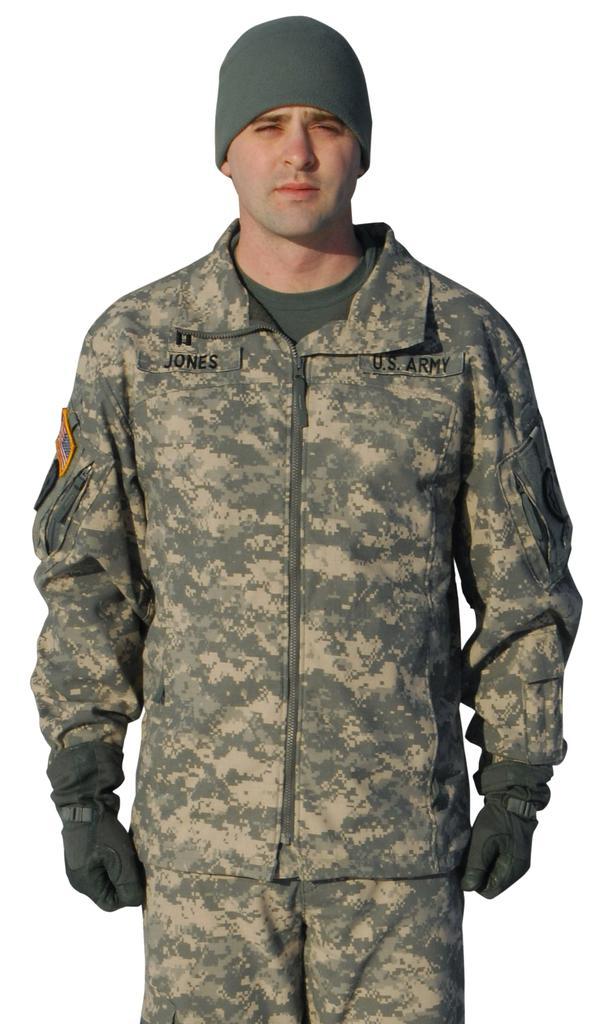Describe this image in one or two sentences. There is one person standing and wearing a cap in the middle of this image. 